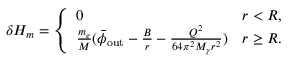Convert formula to latex. <formula><loc_0><loc_0><loc_500><loc_500>\delta H _ { m } = \left \{ \begin{array} { l l } { 0 } & { r < R , } \\ { \frac { m _ { e } } { M } ( \bar { \phi } _ { o u t } - \frac { B } { r } - \frac { Q ^ { 2 } } { 6 4 \pi ^ { 2 } M _ { \gamma } r ^ { 2 } } ) } & { r \geq R . } \end{array}</formula> 